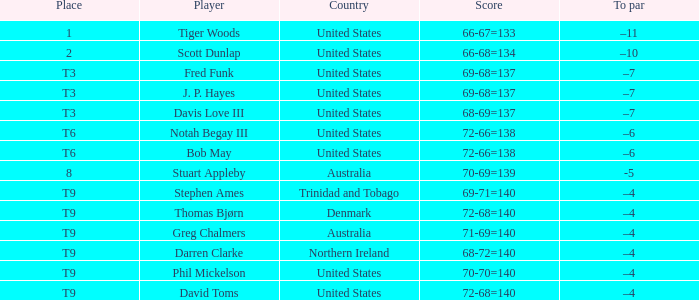What country is Stephen Ames from with a place value of t9? Trinidad and Tobago. 